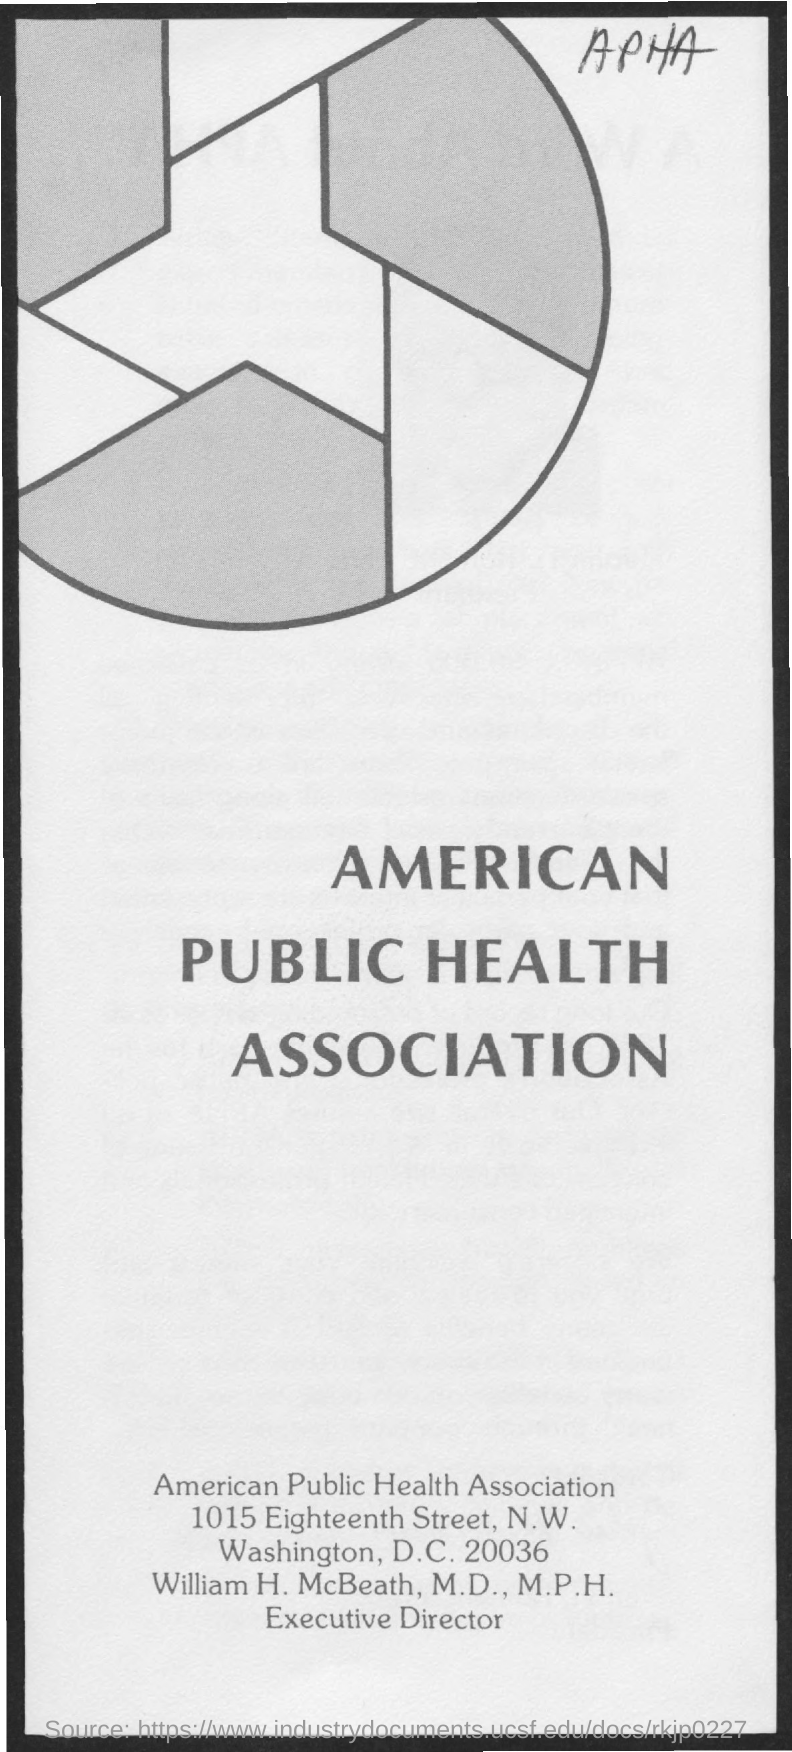Give some essential details in this illustration. The Executive Director of the American Public Health Association is William H. McBeath, M.D., M.P.H. 